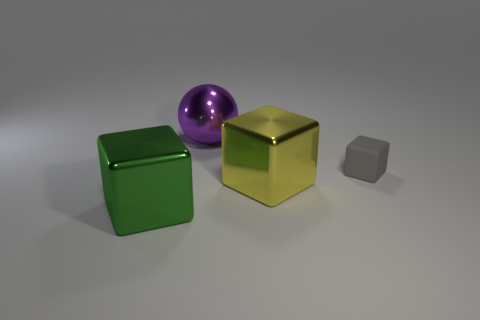Subtract all large blocks. How many blocks are left? 1 Add 2 tiny rubber objects. How many objects exist? 6 Subtract all green cubes. How many cubes are left? 2 Subtract all blocks. How many objects are left? 1 Subtract all blue cylinders. How many gray balls are left? 0 Subtract 0 brown cubes. How many objects are left? 4 Subtract all gray spheres. Subtract all blue cylinders. How many spheres are left? 1 Subtract all large yellow cubes. Subtract all tiny rubber cubes. How many objects are left? 2 Add 1 big purple objects. How many big purple objects are left? 2 Add 3 matte objects. How many matte objects exist? 4 